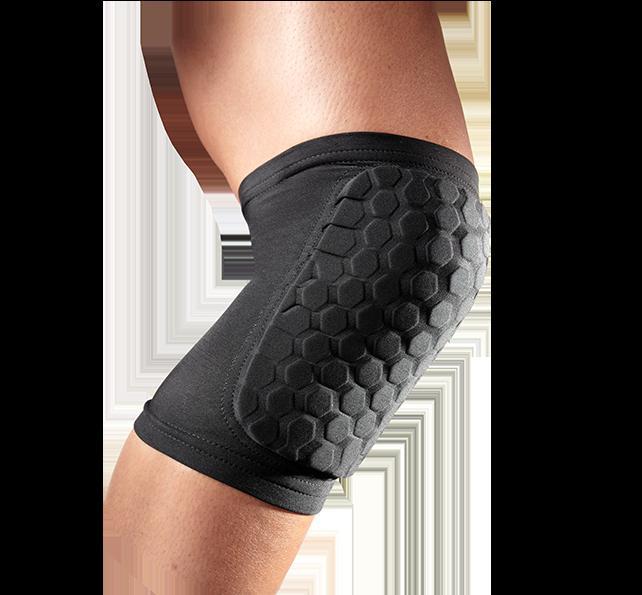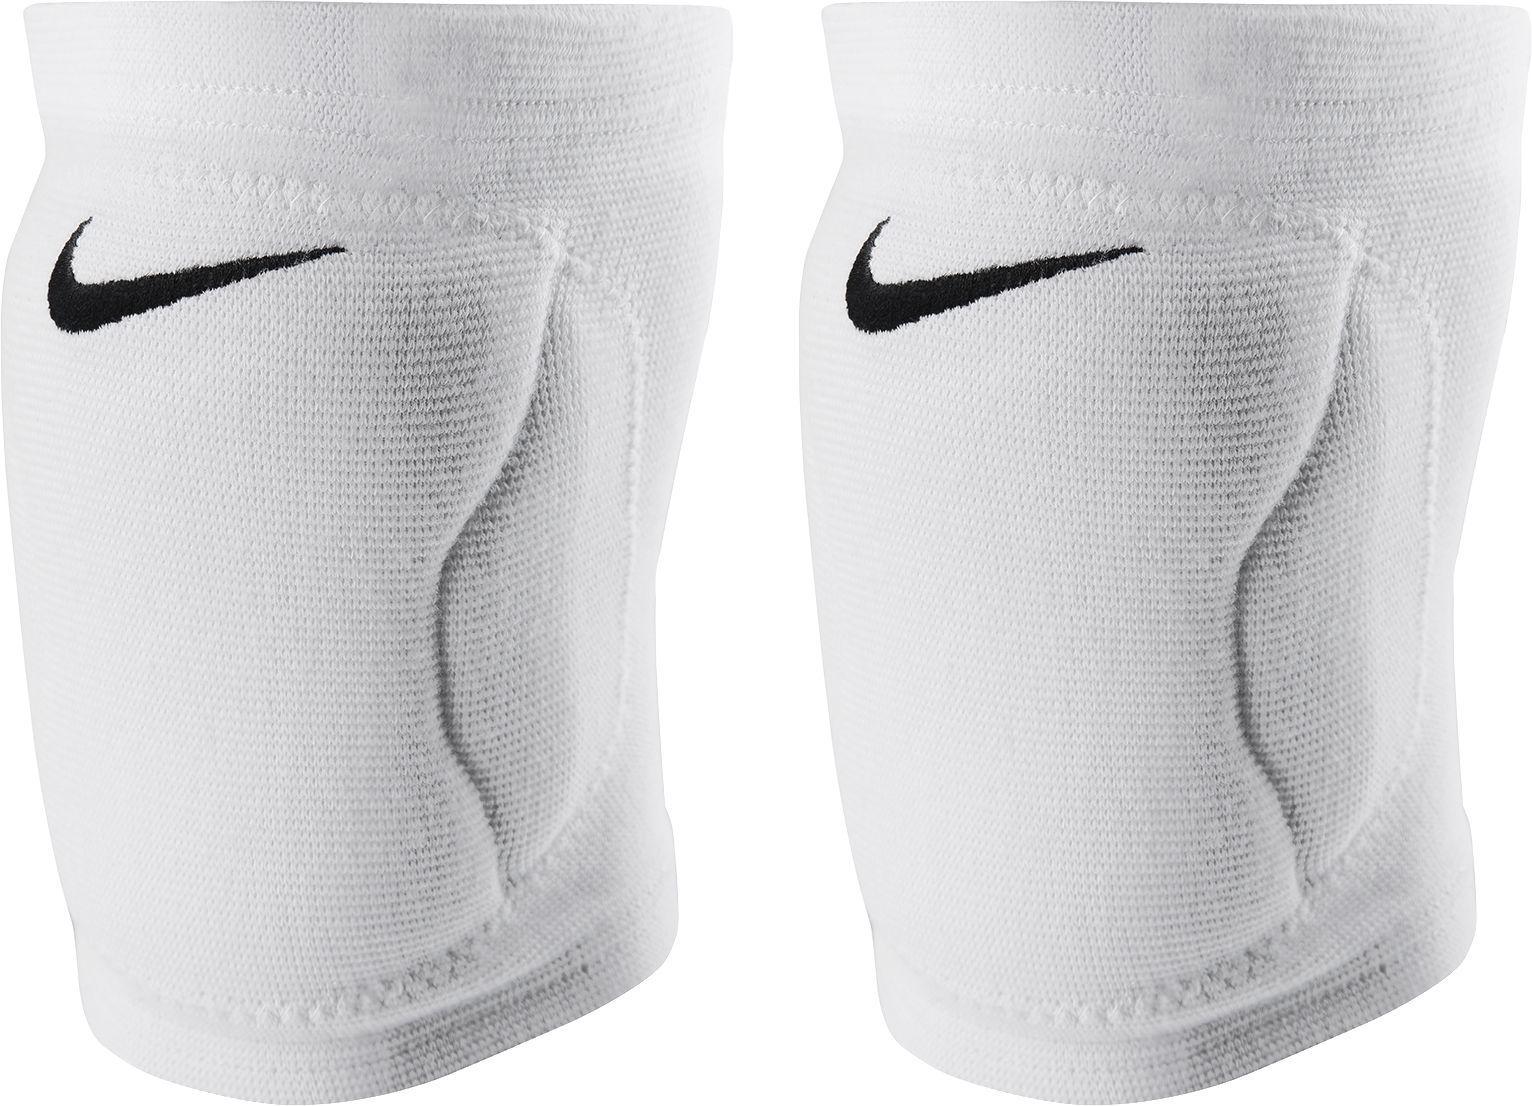The first image is the image on the left, the second image is the image on the right. Assess this claim about the two images: "An image shows a black knee pad modeled on a human leg.". Correct or not? Answer yes or no. Yes. The first image is the image on the left, the second image is the image on the right. Given the left and right images, does the statement "A person is modeling the knee pads in one of the images." hold true? Answer yes or no. Yes. 